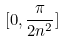<formula> <loc_0><loc_0><loc_500><loc_500>[ 0 , \frac { \pi } { 2 n ^ { 2 } } ]</formula> 